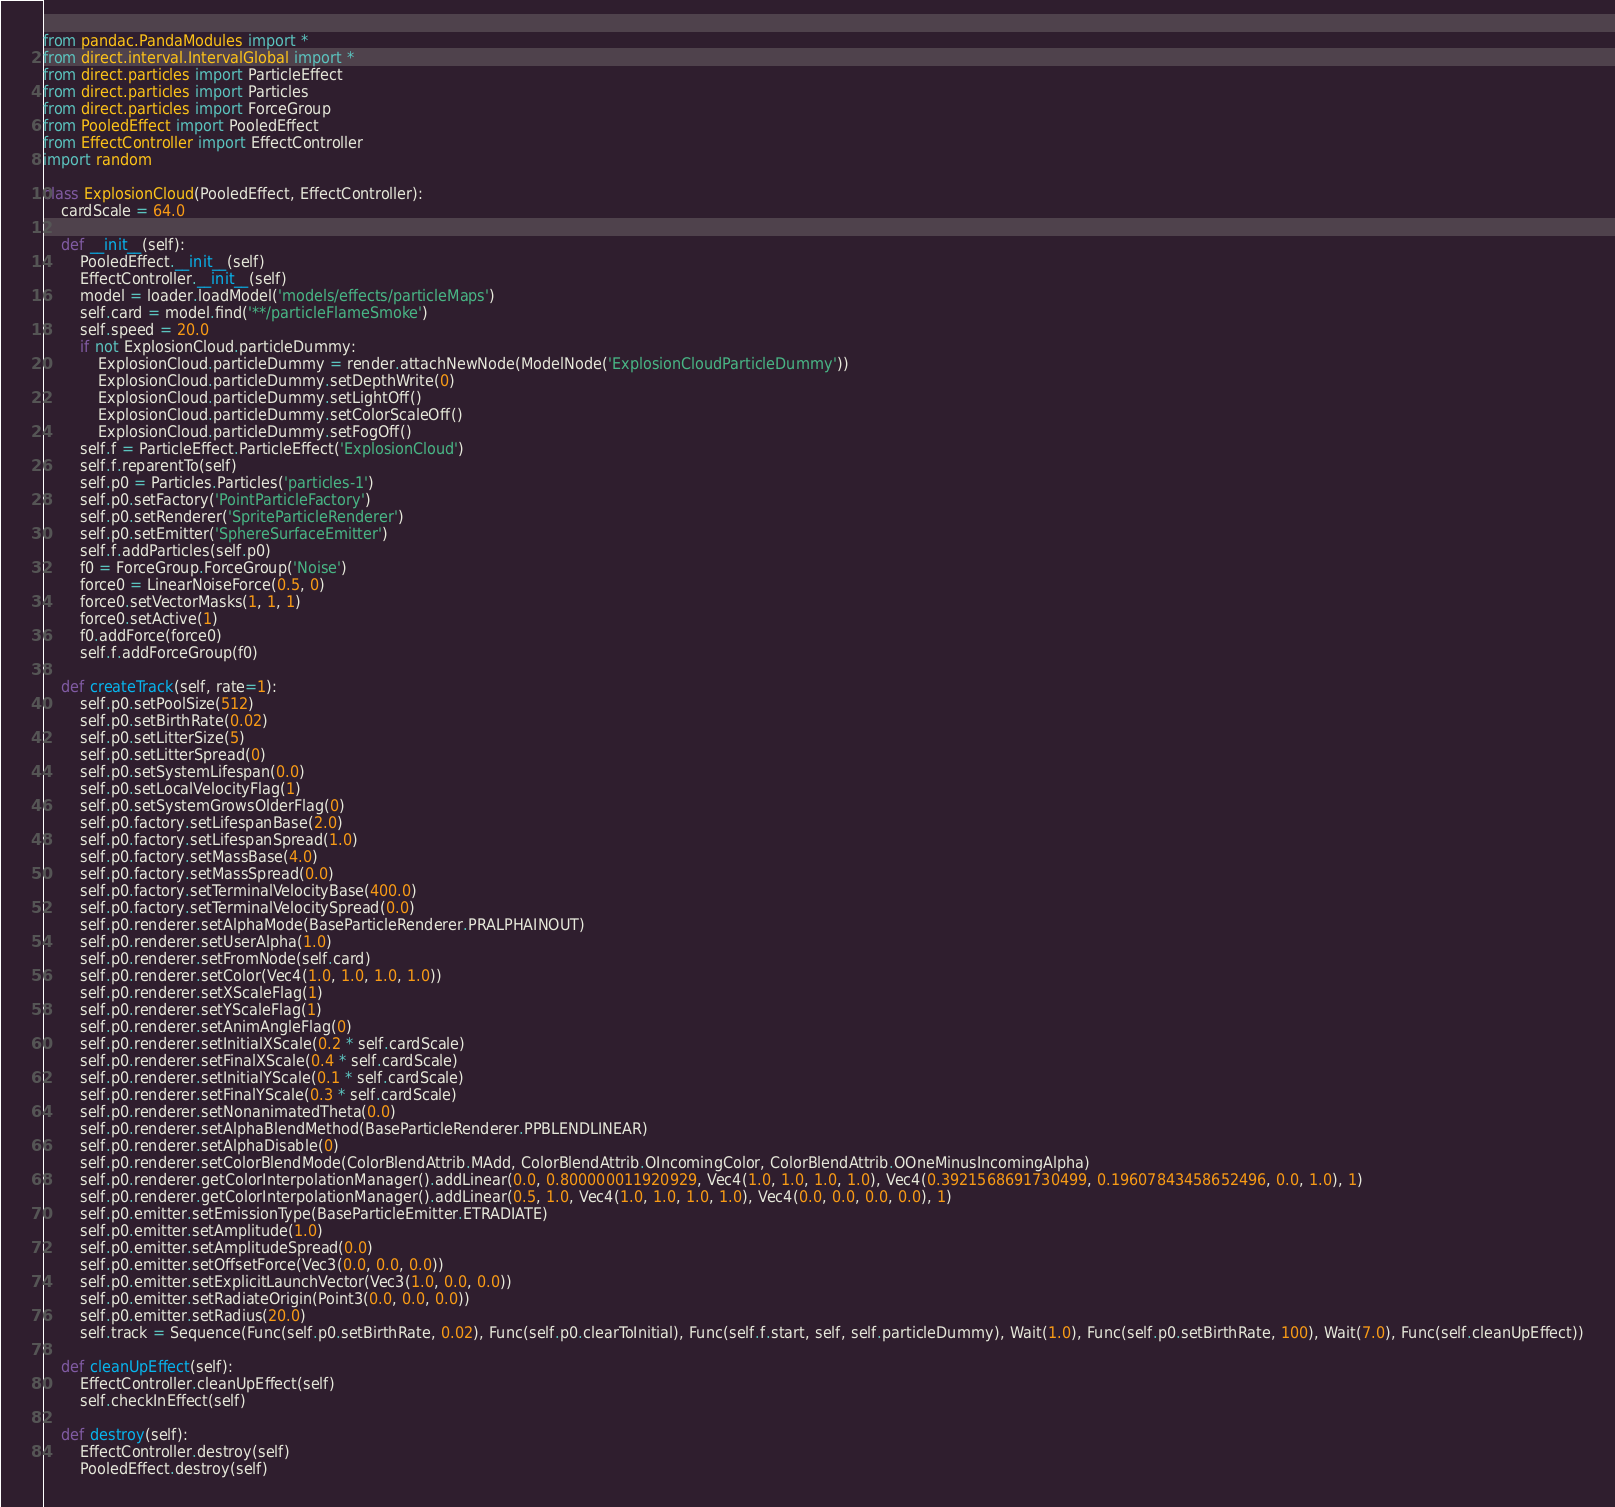<code> <loc_0><loc_0><loc_500><loc_500><_Python_>from pandac.PandaModules import *
from direct.interval.IntervalGlobal import *
from direct.particles import ParticleEffect
from direct.particles import Particles
from direct.particles import ForceGroup
from PooledEffect import PooledEffect
from EffectController import EffectController
import random

class ExplosionCloud(PooledEffect, EffectController):
    cardScale = 64.0

    def __init__(self):
        PooledEffect.__init__(self)
        EffectController.__init__(self)
        model = loader.loadModel('models/effects/particleMaps')
        self.card = model.find('**/particleFlameSmoke')
        self.speed = 20.0
        if not ExplosionCloud.particleDummy:
            ExplosionCloud.particleDummy = render.attachNewNode(ModelNode('ExplosionCloudParticleDummy'))
            ExplosionCloud.particleDummy.setDepthWrite(0)
            ExplosionCloud.particleDummy.setLightOff()
            ExplosionCloud.particleDummy.setColorScaleOff()
            ExplosionCloud.particleDummy.setFogOff()
        self.f = ParticleEffect.ParticleEffect('ExplosionCloud')
        self.f.reparentTo(self)
        self.p0 = Particles.Particles('particles-1')
        self.p0.setFactory('PointParticleFactory')
        self.p0.setRenderer('SpriteParticleRenderer')
        self.p0.setEmitter('SphereSurfaceEmitter')
        self.f.addParticles(self.p0)
        f0 = ForceGroup.ForceGroup('Noise')
        force0 = LinearNoiseForce(0.5, 0)
        force0.setVectorMasks(1, 1, 1)
        force0.setActive(1)
        f0.addForce(force0)
        self.f.addForceGroup(f0)

    def createTrack(self, rate=1):
        self.p0.setPoolSize(512)
        self.p0.setBirthRate(0.02)
        self.p0.setLitterSize(5)
        self.p0.setLitterSpread(0)
        self.p0.setSystemLifespan(0.0)
        self.p0.setLocalVelocityFlag(1)
        self.p0.setSystemGrowsOlderFlag(0)
        self.p0.factory.setLifespanBase(2.0)
        self.p0.factory.setLifespanSpread(1.0)
        self.p0.factory.setMassBase(4.0)
        self.p0.factory.setMassSpread(0.0)
        self.p0.factory.setTerminalVelocityBase(400.0)
        self.p0.factory.setTerminalVelocitySpread(0.0)
        self.p0.renderer.setAlphaMode(BaseParticleRenderer.PRALPHAINOUT)
        self.p0.renderer.setUserAlpha(1.0)
        self.p0.renderer.setFromNode(self.card)
        self.p0.renderer.setColor(Vec4(1.0, 1.0, 1.0, 1.0))
        self.p0.renderer.setXScaleFlag(1)
        self.p0.renderer.setYScaleFlag(1)
        self.p0.renderer.setAnimAngleFlag(0)
        self.p0.renderer.setInitialXScale(0.2 * self.cardScale)
        self.p0.renderer.setFinalXScale(0.4 * self.cardScale)
        self.p0.renderer.setInitialYScale(0.1 * self.cardScale)
        self.p0.renderer.setFinalYScale(0.3 * self.cardScale)
        self.p0.renderer.setNonanimatedTheta(0.0)
        self.p0.renderer.setAlphaBlendMethod(BaseParticleRenderer.PPBLENDLINEAR)
        self.p0.renderer.setAlphaDisable(0)
        self.p0.renderer.setColorBlendMode(ColorBlendAttrib.MAdd, ColorBlendAttrib.OIncomingColor, ColorBlendAttrib.OOneMinusIncomingAlpha)
        self.p0.renderer.getColorInterpolationManager().addLinear(0.0, 0.800000011920929, Vec4(1.0, 1.0, 1.0, 1.0), Vec4(0.3921568691730499, 0.19607843458652496, 0.0, 1.0), 1)
        self.p0.renderer.getColorInterpolationManager().addLinear(0.5, 1.0, Vec4(1.0, 1.0, 1.0, 1.0), Vec4(0.0, 0.0, 0.0, 0.0), 1)
        self.p0.emitter.setEmissionType(BaseParticleEmitter.ETRADIATE)
        self.p0.emitter.setAmplitude(1.0)
        self.p0.emitter.setAmplitudeSpread(0.0)
        self.p0.emitter.setOffsetForce(Vec3(0.0, 0.0, 0.0))
        self.p0.emitter.setExplicitLaunchVector(Vec3(1.0, 0.0, 0.0))
        self.p0.emitter.setRadiateOrigin(Point3(0.0, 0.0, 0.0))
        self.p0.emitter.setRadius(20.0)
        self.track = Sequence(Func(self.p0.setBirthRate, 0.02), Func(self.p0.clearToInitial), Func(self.f.start, self, self.particleDummy), Wait(1.0), Func(self.p0.setBirthRate, 100), Wait(7.0), Func(self.cleanUpEffect))

    def cleanUpEffect(self):
        EffectController.cleanUpEffect(self)
        self.checkInEffect(self)

    def destroy(self):
        EffectController.destroy(self)
        PooledEffect.destroy(self)</code> 